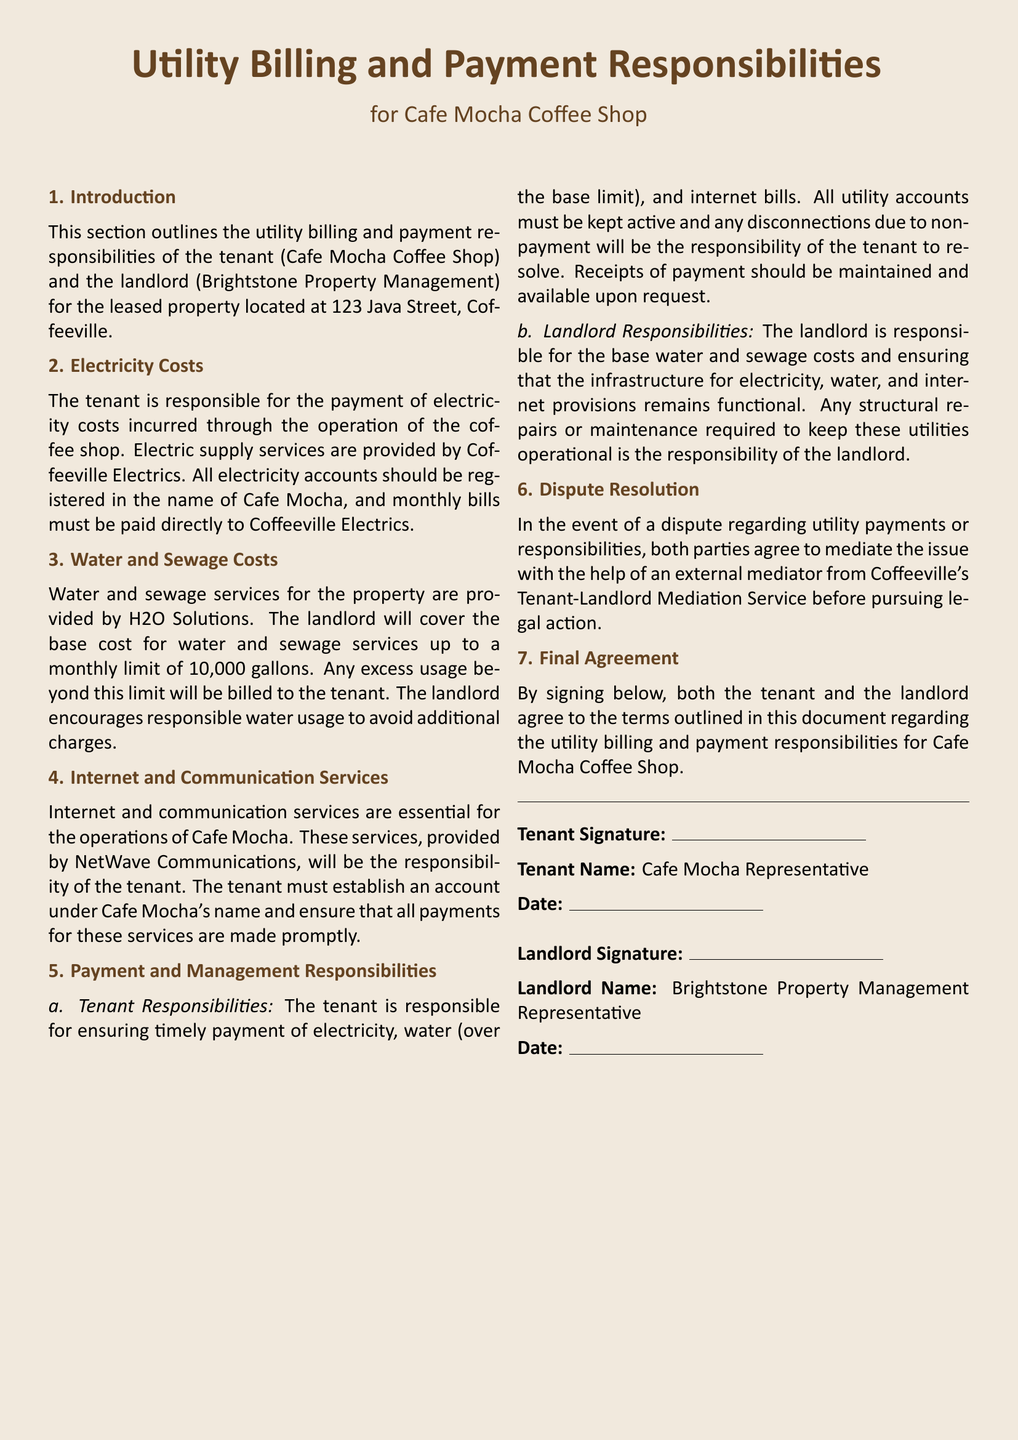What is the name of the coffee shop? The name of the coffee shop is explicitly stated in the document.
Answer: Cafe Mocha Coffee Shop Who provides the electricity services? The document identifies the provider of electricity services for the coffee shop.
Answer: Coffeeville Electrics What is the water usage limit covered by the landlord? The document specifies the maximum amount of water the landlord will cover each month.
Answer: 10,000 gallons Which company provides internet services? The provider of internet services mentioned in the document is clearly stated.
Answer: NetWave Communications Who is responsible for excess water costs? The document outlines who will bear additional charges for water usage.
Answer: Tenant What must the tenant do regarding utility bill payments? The document specifies a requirement placed on the tenant concerning utility bills.
Answer: Ensure timely payment What is the dispute resolution procedure mentioned? The document describes the process to be followed in case of a dispute related to utilities.
Answer: Mediation What must receipts of payment be available for? The document mentions the purpose for which the tenant must maintain payment receipts.
Answer: Upon request What is the landlord responsible for maintaining? The document outlines what the landlord must keep operational.
Answer: Infrastructure for utilities 